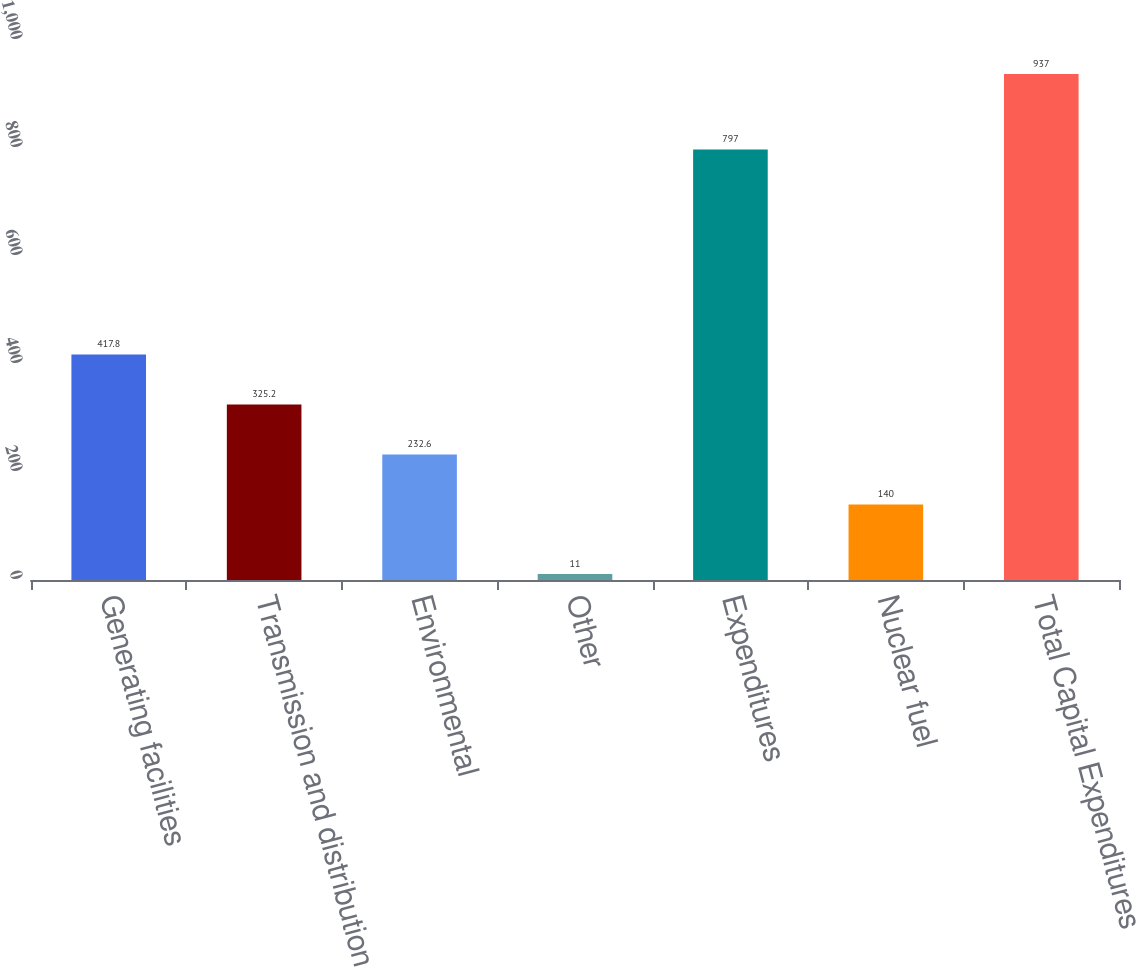Convert chart to OTSL. <chart><loc_0><loc_0><loc_500><loc_500><bar_chart><fcel>Generating facilities<fcel>Transmission and distribution<fcel>Environmental<fcel>Other<fcel>Expenditures<fcel>Nuclear fuel<fcel>Total Capital Expenditures<nl><fcel>417.8<fcel>325.2<fcel>232.6<fcel>11<fcel>797<fcel>140<fcel>937<nl></chart> 